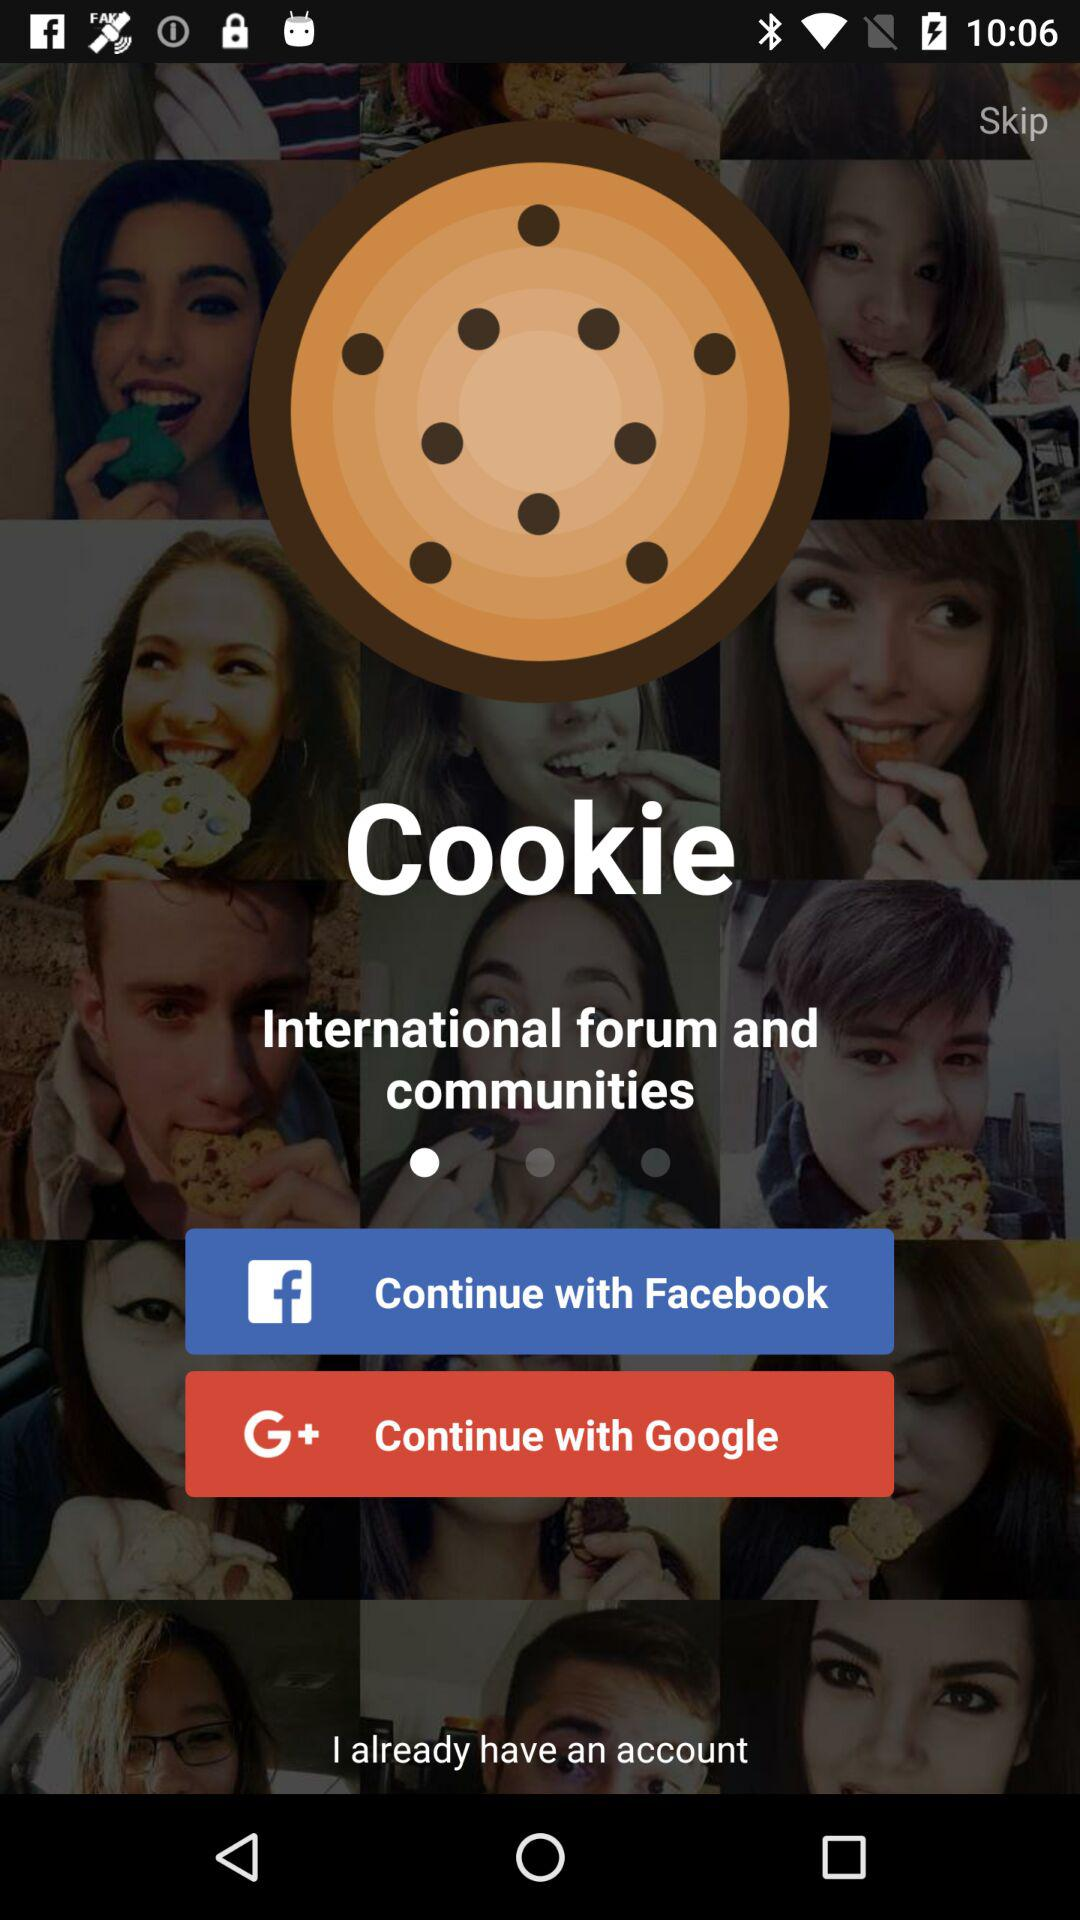What account can be used to continue? The accounts are "Facebook" and "Google". 